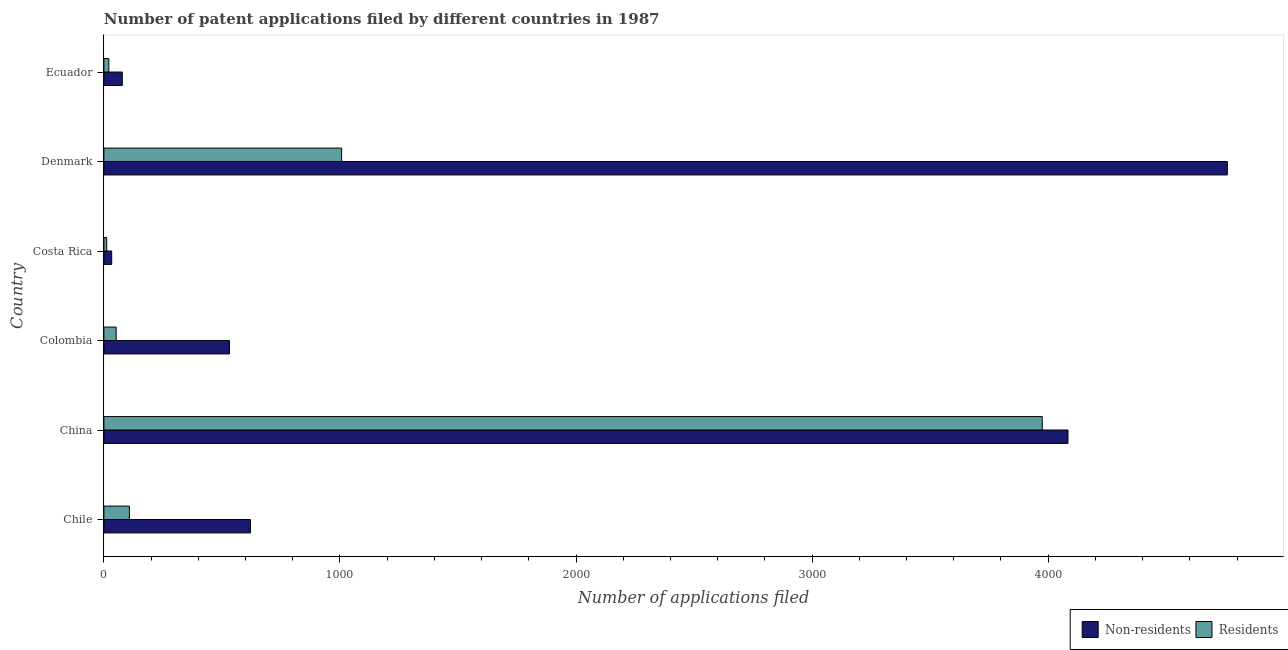How many groups of bars are there?
Ensure brevity in your answer.  6. Are the number of bars per tick equal to the number of legend labels?
Offer a terse response. Yes. How many bars are there on the 1st tick from the top?
Make the answer very short. 2. What is the label of the 1st group of bars from the top?
Your response must be concise. Ecuador. In how many cases, is the number of bars for a given country not equal to the number of legend labels?
Offer a terse response. 0. What is the number of patent applications by non residents in China?
Offer a very short reply. 4084. Across all countries, what is the maximum number of patent applications by residents?
Keep it short and to the point. 3975. Across all countries, what is the minimum number of patent applications by non residents?
Offer a very short reply. 33. In which country was the number of patent applications by residents maximum?
Keep it short and to the point. China. What is the total number of patent applications by non residents in the graph?
Your response must be concise. 1.01e+04. What is the difference between the number of patent applications by non residents in Chile and that in Ecuador?
Ensure brevity in your answer.  543. What is the difference between the number of patent applications by residents in Ecuador and the number of patent applications by non residents in China?
Provide a succinct answer. -4063. What is the average number of patent applications by residents per country?
Keep it short and to the point. 862.5. What is the difference between the number of patent applications by non residents and number of patent applications by residents in Ecuador?
Keep it short and to the point. 57. In how many countries, is the number of patent applications by residents greater than 1000 ?
Make the answer very short. 2. What is the ratio of the number of patent applications by non residents in Colombia to that in Ecuador?
Your response must be concise. 6.82. Is the number of patent applications by residents in Chile less than that in Colombia?
Provide a short and direct response. No. Is the difference between the number of patent applications by residents in Denmark and Ecuador greater than the difference between the number of patent applications by non residents in Denmark and Ecuador?
Ensure brevity in your answer.  No. What is the difference between the highest and the second highest number of patent applications by residents?
Give a very brief answer. 2968. What is the difference between the highest and the lowest number of patent applications by residents?
Keep it short and to the point. 3963. What does the 1st bar from the top in Costa Rica represents?
Offer a terse response. Residents. What does the 1st bar from the bottom in Denmark represents?
Offer a terse response. Non-residents. Are all the bars in the graph horizontal?
Ensure brevity in your answer.  Yes. What is the difference between two consecutive major ticks on the X-axis?
Provide a short and direct response. 1000. Are the values on the major ticks of X-axis written in scientific E-notation?
Offer a very short reply. No. Where does the legend appear in the graph?
Your answer should be compact. Bottom right. What is the title of the graph?
Your answer should be compact. Number of patent applications filed by different countries in 1987. Does "Fixed telephone" appear as one of the legend labels in the graph?
Ensure brevity in your answer.  No. What is the label or title of the X-axis?
Offer a terse response. Number of applications filed. What is the label or title of the Y-axis?
Your answer should be very brief. Country. What is the Number of applications filed of Non-residents in Chile?
Provide a succinct answer. 621. What is the Number of applications filed of Residents in Chile?
Your response must be concise. 108. What is the Number of applications filed in Non-residents in China?
Make the answer very short. 4084. What is the Number of applications filed of Residents in China?
Your answer should be very brief. 3975. What is the Number of applications filed in Non-residents in Colombia?
Give a very brief answer. 532. What is the Number of applications filed in Residents in Colombia?
Provide a succinct answer. 52. What is the Number of applications filed of Non-residents in Denmark?
Your answer should be very brief. 4759. What is the Number of applications filed of Residents in Denmark?
Offer a terse response. 1007. What is the Number of applications filed in Residents in Ecuador?
Make the answer very short. 21. Across all countries, what is the maximum Number of applications filed in Non-residents?
Ensure brevity in your answer.  4759. Across all countries, what is the maximum Number of applications filed of Residents?
Provide a short and direct response. 3975. Across all countries, what is the minimum Number of applications filed in Non-residents?
Give a very brief answer. 33. What is the total Number of applications filed in Non-residents in the graph?
Offer a terse response. 1.01e+04. What is the total Number of applications filed of Residents in the graph?
Your answer should be very brief. 5175. What is the difference between the Number of applications filed in Non-residents in Chile and that in China?
Your answer should be very brief. -3463. What is the difference between the Number of applications filed in Residents in Chile and that in China?
Your response must be concise. -3867. What is the difference between the Number of applications filed in Non-residents in Chile and that in Colombia?
Provide a short and direct response. 89. What is the difference between the Number of applications filed in Residents in Chile and that in Colombia?
Give a very brief answer. 56. What is the difference between the Number of applications filed of Non-residents in Chile and that in Costa Rica?
Offer a terse response. 588. What is the difference between the Number of applications filed in Residents in Chile and that in Costa Rica?
Your answer should be very brief. 96. What is the difference between the Number of applications filed in Non-residents in Chile and that in Denmark?
Give a very brief answer. -4138. What is the difference between the Number of applications filed in Residents in Chile and that in Denmark?
Ensure brevity in your answer.  -899. What is the difference between the Number of applications filed of Non-residents in Chile and that in Ecuador?
Your answer should be compact. 543. What is the difference between the Number of applications filed in Non-residents in China and that in Colombia?
Give a very brief answer. 3552. What is the difference between the Number of applications filed in Residents in China and that in Colombia?
Provide a short and direct response. 3923. What is the difference between the Number of applications filed in Non-residents in China and that in Costa Rica?
Offer a very short reply. 4051. What is the difference between the Number of applications filed in Residents in China and that in Costa Rica?
Your answer should be very brief. 3963. What is the difference between the Number of applications filed in Non-residents in China and that in Denmark?
Keep it short and to the point. -675. What is the difference between the Number of applications filed of Residents in China and that in Denmark?
Make the answer very short. 2968. What is the difference between the Number of applications filed of Non-residents in China and that in Ecuador?
Ensure brevity in your answer.  4006. What is the difference between the Number of applications filed of Residents in China and that in Ecuador?
Your answer should be compact. 3954. What is the difference between the Number of applications filed of Non-residents in Colombia and that in Costa Rica?
Your answer should be compact. 499. What is the difference between the Number of applications filed of Residents in Colombia and that in Costa Rica?
Keep it short and to the point. 40. What is the difference between the Number of applications filed of Non-residents in Colombia and that in Denmark?
Offer a very short reply. -4227. What is the difference between the Number of applications filed of Residents in Colombia and that in Denmark?
Keep it short and to the point. -955. What is the difference between the Number of applications filed in Non-residents in Colombia and that in Ecuador?
Provide a succinct answer. 454. What is the difference between the Number of applications filed in Residents in Colombia and that in Ecuador?
Offer a very short reply. 31. What is the difference between the Number of applications filed in Non-residents in Costa Rica and that in Denmark?
Keep it short and to the point. -4726. What is the difference between the Number of applications filed of Residents in Costa Rica and that in Denmark?
Make the answer very short. -995. What is the difference between the Number of applications filed in Non-residents in Costa Rica and that in Ecuador?
Provide a succinct answer. -45. What is the difference between the Number of applications filed in Non-residents in Denmark and that in Ecuador?
Offer a terse response. 4681. What is the difference between the Number of applications filed of Residents in Denmark and that in Ecuador?
Offer a very short reply. 986. What is the difference between the Number of applications filed in Non-residents in Chile and the Number of applications filed in Residents in China?
Ensure brevity in your answer.  -3354. What is the difference between the Number of applications filed in Non-residents in Chile and the Number of applications filed in Residents in Colombia?
Your response must be concise. 569. What is the difference between the Number of applications filed in Non-residents in Chile and the Number of applications filed in Residents in Costa Rica?
Give a very brief answer. 609. What is the difference between the Number of applications filed in Non-residents in Chile and the Number of applications filed in Residents in Denmark?
Offer a very short reply. -386. What is the difference between the Number of applications filed of Non-residents in Chile and the Number of applications filed of Residents in Ecuador?
Give a very brief answer. 600. What is the difference between the Number of applications filed in Non-residents in China and the Number of applications filed in Residents in Colombia?
Your answer should be very brief. 4032. What is the difference between the Number of applications filed of Non-residents in China and the Number of applications filed of Residents in Costa Rica?
Ensure brevity in your answer.  4072. What is the difference between the Number of applications filed of Non-residents in China and the Number of applications filed of Residents in Denmark?
Offer a very short reply. 3077. What is the difference between the Number of applications filed in Non-residents in China and the Number of applications filed in Residents in Ecuador?
Give a very brief answer. 4063. What is the difference between the Number of applications filed of Non-residents in Colombia and the Number of applications filed of Residents in Costa Rica?
Ensure brevity in your answer.  520. What is the difference between the Number of applications filed in Non-residents in Colombia and the Number of applications filed in Residents in Denmark?
Provide a short and direct response. -475. What is the difference between the Number of applications filed of Non-residents in Colombia and the Number of applications filed of Residents in Ecuador?
Ensure brevity in your answer.  511. What is the difference between the Number of applications filed of Non-residents in Costa Rica and the Number of applications filed of Residents in Denmark?
Your response must be concise. -974. What is the difference between the Number of applications filed of Non-residents in Costa Rica and the Number of applications filed of Residents in Ecuador?
Make the answer very short. 12. What is the difference between the Number of applications filed of Non-residents in Denmark and the Number of applications filed of Residents in Ecuador?
Offer a very short reply. 4738. What is the average Number of applications filed of Non-residents per country?
Offer a terse response. 1684.5. What is the average Number of applications filed of Residents per country?
Your response must be concise. 862.5. What is the difference between the Number of applications filed of Non-residents and Number of applications filed of Residents in Chile?
Keep it short and to the point. 513. What is the difference between the Number of applications filed of Non-residents and Number of applications filed of Residents in China?
Offer a terse response. 109. What is the difference between the Number of applications filed in Non-residents and Number of applications filed in Residents in Colombia?
Make the answer very short. 480. What is the difference between the Number of applications filed of Non-residents and Number of applications filed of Residents in Denmark?
Make the answer very short. 3752. What is the difference between the Number of applications filed in Non-residents and Number of applications filed in Residents in Ecuador?
Your response must be concise. 57. What is the ratio of the Number of applications filed in Non-residents in Chile to that in China?
Make the answer very short. 0.15. What is the ratio of the Number of applications filed of Residents in Chile to that in China?
Give a very brief answer. 0.03. What is the ratio of the Number of applications filed of Non-residents in Chile to that in Colombia?
Make the answer very short. 1.17. What is the ratio of the Number of applications filed of Residents in Chile to that in Colombia?
Provide a short and direct response. 2.08. What is the ratio of the Number of applications filed in Non-residents in Chile to that in Costa Rica?
Provide a succinct answer. 18.82. What is the ratio of the Number of applications filed in Residents in Chile to that in Costa Rica?
Ensure brevity in your answer.  9. What is the ratio of the Number of applications filed in Non-residents in Chile to that in Denmark?
Keep it short and to the point. 0.13. What is the ratio of the Number of applications filed in Residents in Chile to that in Denmark?
Your answer should be compact. 0.11. What is the ratio of the Number of applications filed in Non-residents in Chile to that in Ecuador?
Make the answer very short. 7.96. What is the ratio of the Number of applications filed in Residents in Chile to that in Ecuador?
Your response must be concise. 5.14. What is the ratio of the Number of applications filed in Non-residents in China to that in Colombia?
Give a very brief answer. 7.68. What is the ratio of the Number of applications filed of Residents in China to that in Colombia?
Keep it short and to the point. 76.44. What is the ratio of the Number of applications filed of Non-residents in China to that in Costa Rica?
Your answer should be very brief. 123.76. What is the ratio of the Number of applications filed in Residents in China to that in Costa Rica?
Your response must be concise. 331.25. What is the ratio of the Number of applications filed of Non-residents in China to that in Denmark?
Your response must be concise. 0.86. What is the ratio of the Number of applications filed in Residents in China to that in Denmark?
Make the answer very short. 3.95. What is the ratio of the Number of applications filed in Non-residents in China to that in Ecuador?
Your response must be concise. 52.36. What is the ratio of the Number of applications filed of Residents in China to that in Ecuador?
Keep it short and to the point. 189.29. What is the ratio of the Number of applications filed of Non-residents in Colombia to that in Costa Rica?
Your response must be concise. 16.12. What is the ratio of the Number of applications filed in Residents in Colombia to that in Costa Rica?
Keep it short and to the point. 4.33. What is the ratio of the Number of applications filed in Non-residents in Colombia to that in Denmark?
Make the answer very short. 0.11. What is the ratio of the Number of applications filed of Residents in Colombia to that in Denmark?
Ensure brevity in your answer.  0.05. What is the ratio of the Number of applications filed in Non-residents in Colombia to that in Ecuador?
Provide a short and direct response. 6.82. What is the ratio of the Number of applications filed in Residents in Colombia to that in Ecuador?
Provide a succinct answer. 2.48. What is the ratio of the Number of applications filed of Non-residents in Costa Rica to that in Denmark?
Your answer should be compact. 0.01. What is the ratio of the Number of applications filed in Residents in Costa Rica to that in Denmark?
Your response must be concise. 0.01. What is the ratio of the Number of applications filed of Non-residents in Costa Rica to that in Ecuador?
Ensure brevity in your answer.  0.42. What is the ratio of the Number of applications filed of Residents in Costa Rica to that in Ecuador?
Make the answer very short. 0.57. What is the ratio of the Number of applications filed of Non-residents in Denmark to that in Ecuador?
Your answer should be very brief. 61.01. What is the ratio of the Number of applications filed in Residents in Denmark to that in Ecuador?
Provide a short and direct response. 47.95. What is the difference between the highest and the second highest Number of applications filed in Non-residents?
Your response must be concise. 675. What is the difference between the highest and the second highest Number of applications filed in Residents?
Ensure brevity in your answer.  2968. What is the difference between the highest and the lowest Number of applications filed of Non-residents?
Offer a terse response. 4726. What is the difference between the highest and the lowest Number of applications filed in Residents?
Ensure brevity in your answer.  3963. 